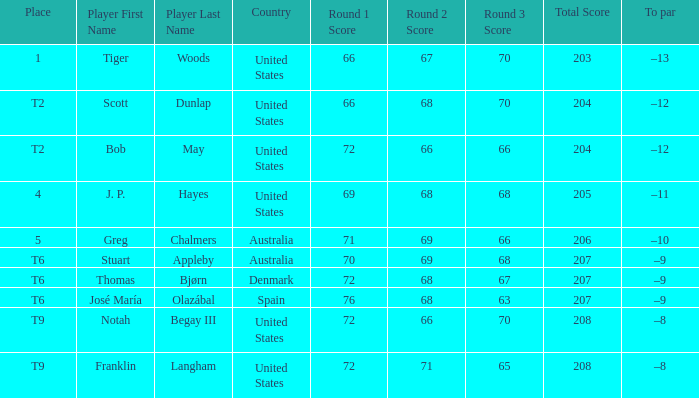What country is player thomas bjørn from? Denmark. 